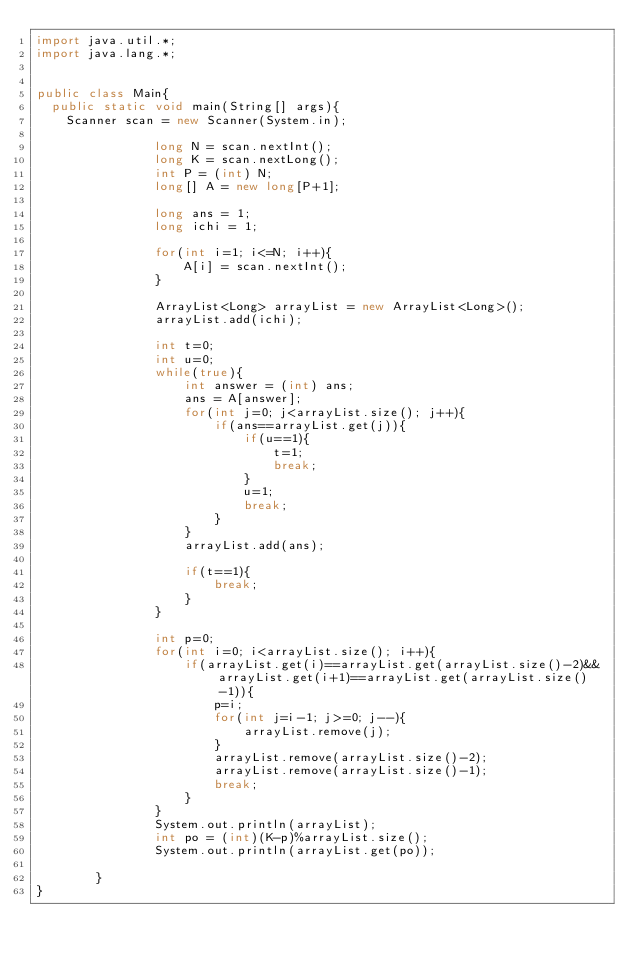<code> <loc_0><loc_0><loc_500><loc_500><_Java_>import java.util.*; 
import java.lang.*; 


public class Main{
	public static void main(String[] args){
		Scanner scan = new Scanner(System.in);
                
                long N = scan.nextInt();
                long K = scan.nextLong();
                int P = (int) N;
                long[] A = new long[P+1];
                
                long ans = 1;
                long ichi = 1;
                
                for(int i=1; i<=N; i++){
                    A[i] = scan.nextInt();
                }

                ArrayList<Long> arrayList = new ArrayList<Long>();
                arrayList.add(ichi);
                
                int t=0;
                int u=0;
                while(true){
                    int answer = (int) ans;
                    ans = A[answer];
                    for(int j=0; j<arrayList.size(); j++){
                        if(ans==arrayList.get(j)){
                            if(u==1){
                                t=1;
                                break;
                            }
                            u=1;
                            break;
                        }
                    }
                    arrayList.add(ans);
        
                    if(t==1){
                        break;
                    }
                }
                
                int p=0;
                for(int i=0; i<arrayList.size(); i++){
                    if(arrayList.get(i)==arrayList.get(arrayList.size()-2)&&arrayList.get(i+1)==arrayList.get(arrayList.size()-1)){
                        p=i;
                        for(int j=i-1; j>=0; j--){
                            arrayList.remove(j);
                        }
                        arrayList.remove(arrayList.size()-2);
                        arrayList.remove(arrayList.size()-1);
                        break;
                    }
                }
                System.out.println(arrayList);
                int po = (int)(K-p)%arrayList.size();
                System.out.println(arrayList.get(po));
              
        }
}</code> 